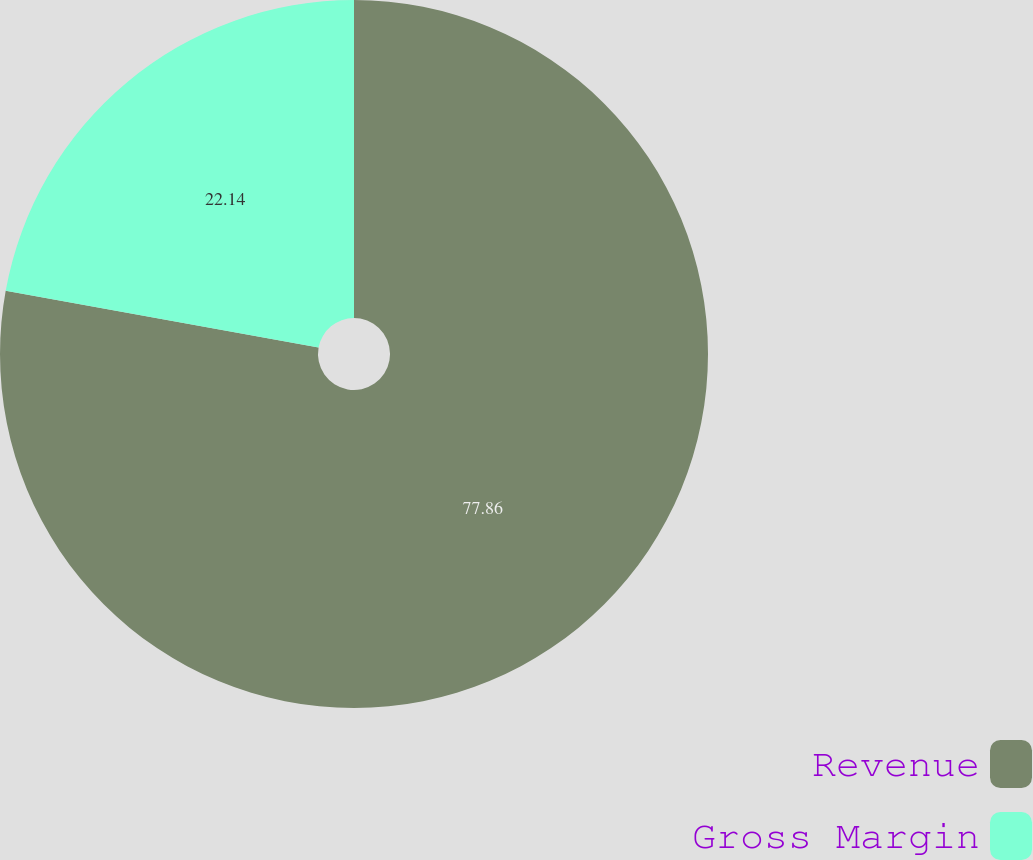Convert chart. <chart><loc_0><loc_0><loc_500><loc_500><pie_chart><fcel>Revenue<fcel>Gross Margin<nl><fcel>77.86%<fcel>22.14%<nl></chart> 